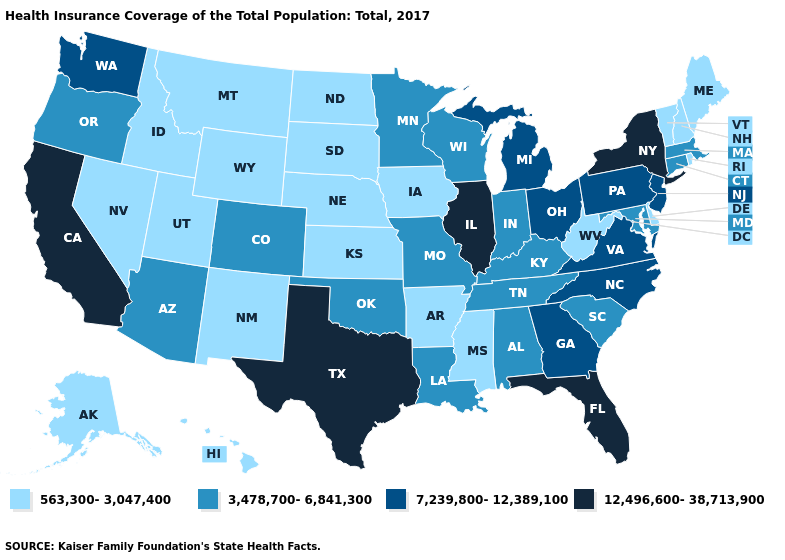What is the value of Hawaii?
Give a very brief answer. 563,300-3,047,400. Which states have the highest value in the USA?
Answer briefly. California, Florida, Illinois, New York, Texas. Among the states that border Georgia , which have the lowest value?
Be succinct. Alabama, South Carolina, Tennessee. Does New York have the highest value in the Northeast?
Be succinct. Yes. What is the lowest value in the USA?
Write a very short answer. 563,300-3,047,400. What is the value of Arizona?
Be succinct. 3,478,700-6,841,300. What is the value of Louisiana?
Quick response, please. 3,478,700-6,841,300. Which states have the lowest value in the Northeast?
Write a very short answer. Maine, New Hampshire, Rhode Island, Vermont. Does Kentucky have a higher value than Iowa?
Keep it brief. Yes. What is the lowest value in the MidWest?
Quick response, please. 563,300-3,047,400. Among the states that border Minnesota , which have the highest value?
Write a very short answer. Wisconsin. What is the value of Arizona?
Concise answer only. 3,478,700-6,841,300. What is the highest value in the MidWest ?
Keep it brief. 12,496,600-38,713,900. Does Florida have the highest value in the South?
Quick response, please. Yes. 